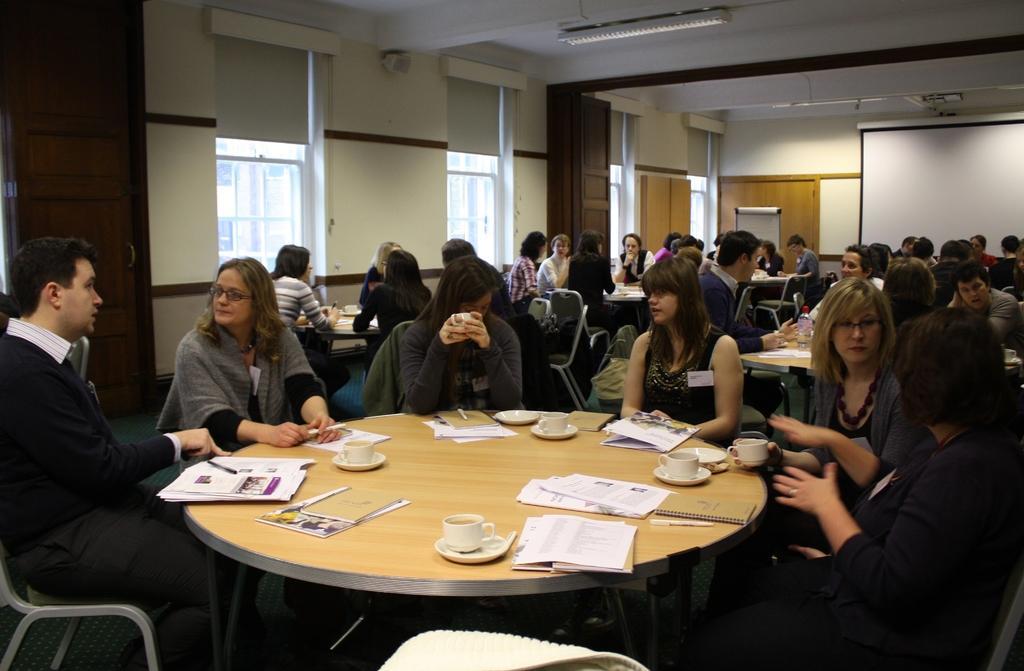Describe this image in one or two sentences. In this image there are group of people sitting in chairs ,another group of people sitting in chairs ,another group of people sitting in chairs and in the table there are cup,saucer ,book,pen and a notepad and a the back ground there is window,speaker , light , screen attached to the wall. 